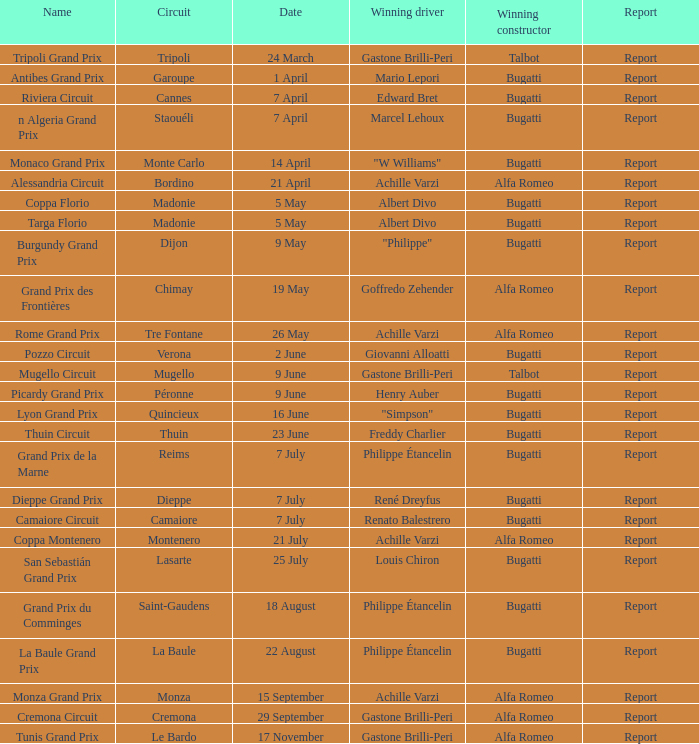What appellation is held by a triumphant bugatti constructor and a winning louis chiron driver? San Sebastián Grand Prix. 